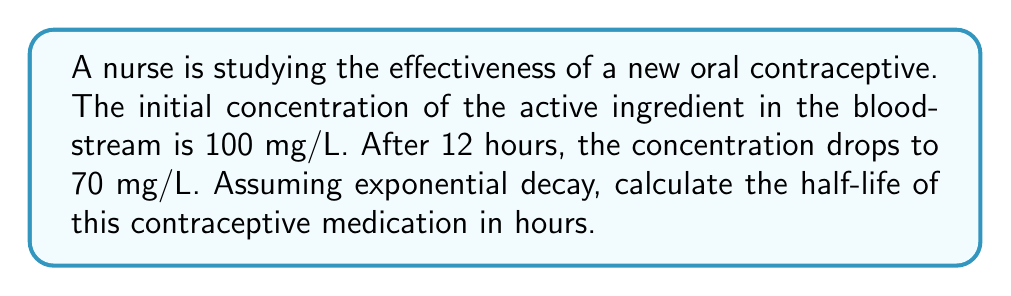Can you answer this question? To solve this problem, we'll use the exponential decay formula and the given information to determine the half-life.

1. The exponential decay formula is:
   $$ A(t) = A_0 \cdot e^{-kt} $$
   where $A(t)$ is the amount at time $t$, $A_0$ is the initial amount, $k$ is the decay constant, and $t$ is time.

2. We know:
   $A_0 = 100$ mg/L
   $A(12) = 70$ mg/L
   $t = 12$ hours

3. Substitute these values into the formula:
   $$ 70 = 100 \cdot e^{-12k} $$

4. Divide both sides by 100:
   $$ 0.7 = e^{-12k} $$

5. Take the natural log of both sides:
   $$ \ln(0.7) = -12k $$

6. Solve for $k$:
   $$ k = -\frac{\ln(0.7)}{12} \approx 0.0297 $$

7. The half-life formula is:
   $$ t_{1/2} = \frac{\ln(2)}{k} $$

8. Substitute the value of $k$:
   $$ t_{1/2} = \frac{\ln(2)}{0.0297} \approx 23.34 $$

Therefore, the half-life of the contraceptive medication is approximately 23.34 hours.
Answer: 23.34 hours 